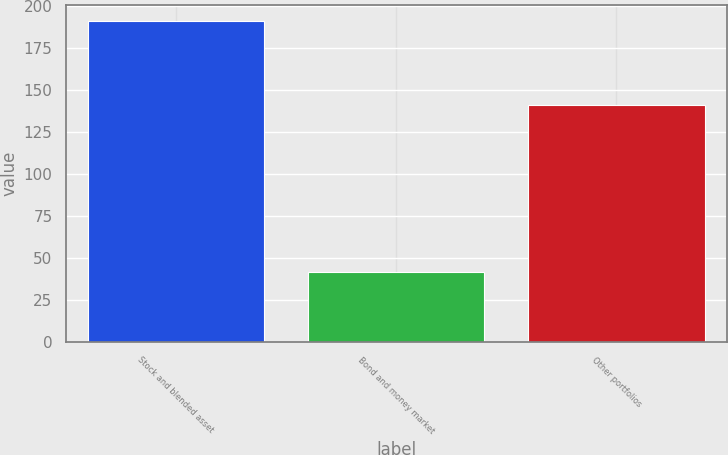Convert chart. <chart><loc_0><loc_0><loc_500><loc_500><bar_chart><fcel>Stock and blended asset<fcel>Bond and money market<fcel>Other portfolios<nl><fcel>191.1<fcel>41.7<fcel>141.4<nl></chart> 